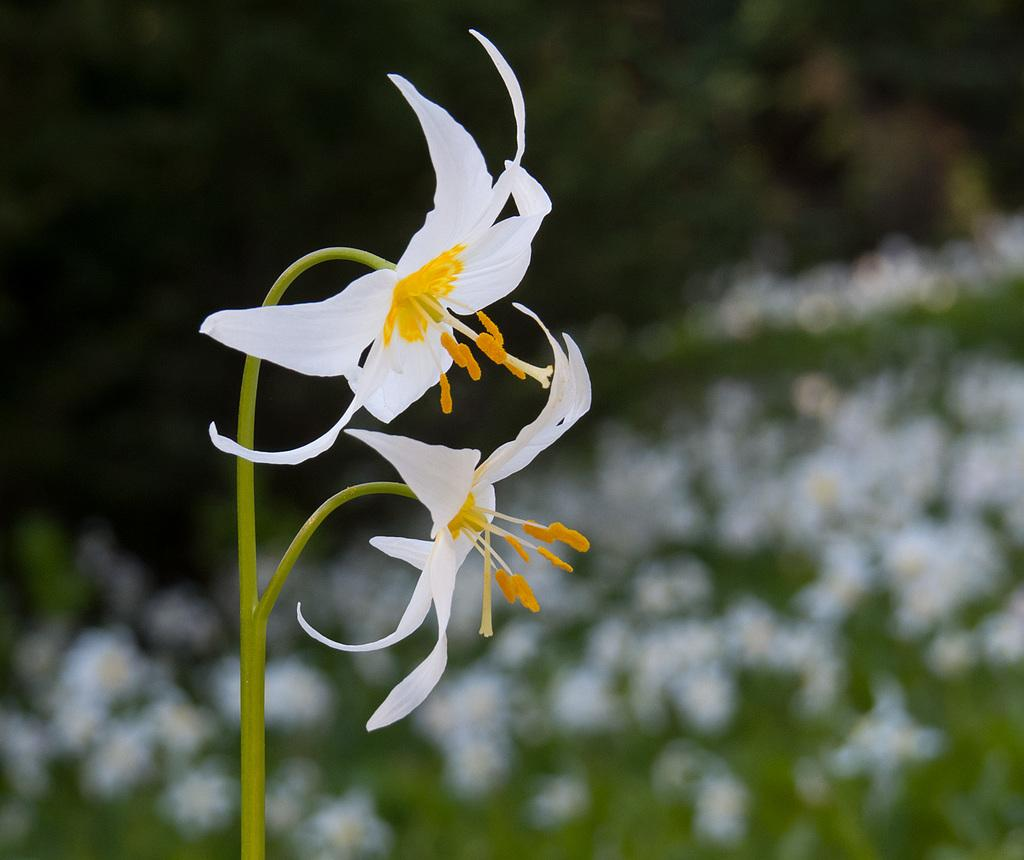What type of plants can be seen in the image? There are flowers in the image. What color are the flowers in the image? The flowers are white in color. What type of cactus can be seen in the image? There is no cactus present in the image; it features white flowers. 